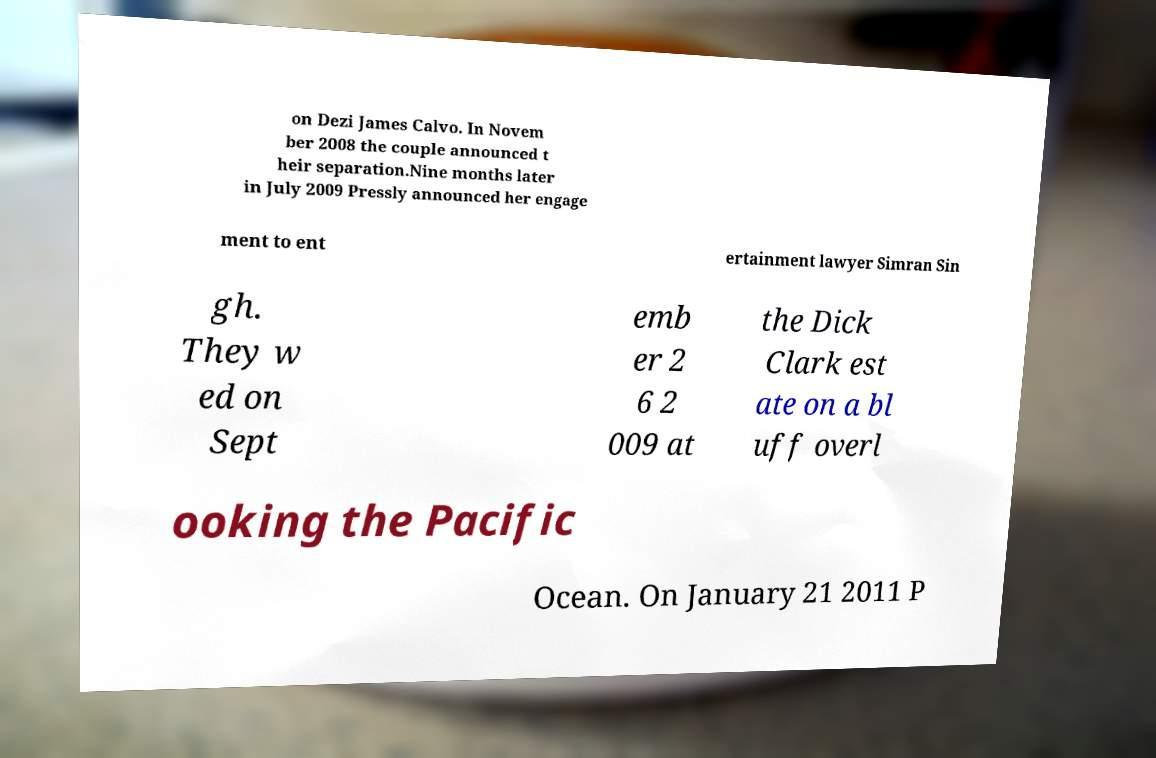Could you extract and type out the text from this image? on Dezi James Calvo. In Novem ber 2008 the couple announced t heir separation.Nine months later in July 2009 Pressly announced her engage ment to ent ertainment lawyer Simran Sin gh. They w ed on Sept emb er 2 6 2 009 at the Dick Clark est ate on a bl uff overl ooking the Pacific Ocean. On January 21 2011 P 